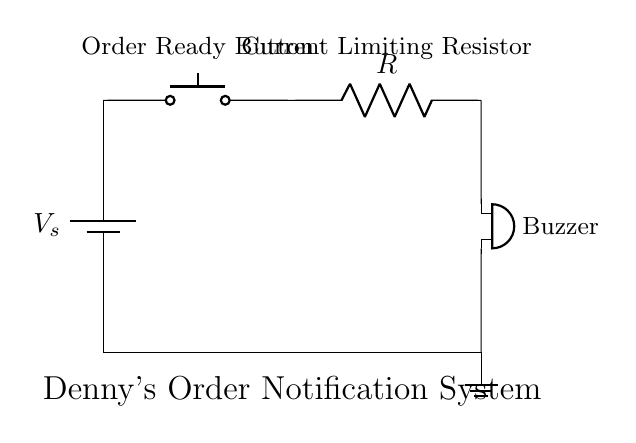What is the component that activates the buzzer? The component that activates the buzzer is the push button switch. When the button is pressed, it completes the circuit, allowing current to flow and turns on the buzzer.
Answer: push button What does the resistor do in this circuit? The resistor limits the current flowing to the buzzer to prevent it from drawing too much current, which could damage it. Resistors are typically used for current control in circuits.
Answer: limit current What is the purpose of the buzzer? The purpose of the buzzer is to provide an audible notification to indicate that an order is ready. It sounds when the circuit is completed by pressing the button.
Answer: notification How many main components are in the circuit? There are four main components in the circuit: a battery, a push button, a resistor, and a buzzer. Each component plays a critical role in the functionality of the system.
Answer: four What does the battery represent in the circuit? The battery represents the power source that provides the necessary voltage to drive the circuit components, enabling them to operate. It also stores energy for the circuit to function.
Answer: power source 